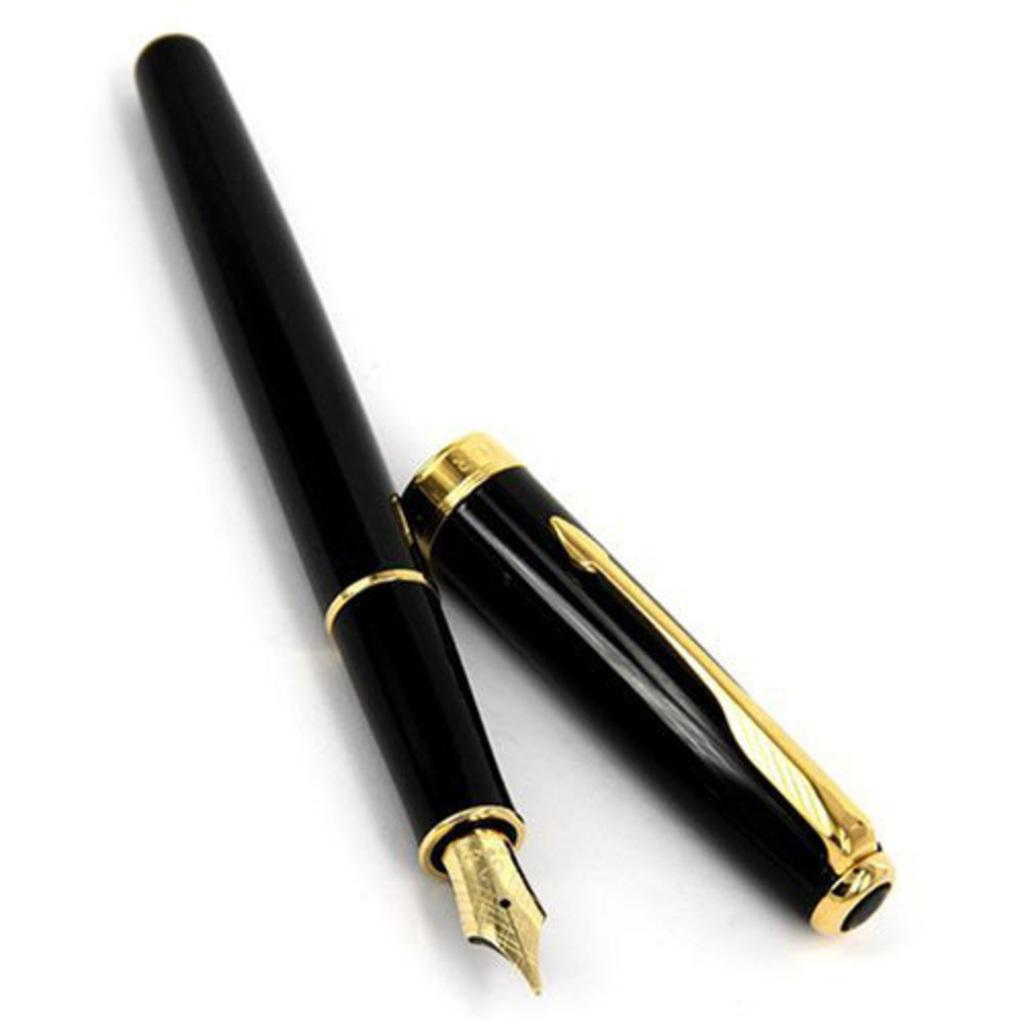What object can be seen in the image? There is a pen in the image. Can you describe the pen's appearance? The pen is black and gold in color. How many apples are hanging from the pen in the image? There are no apples present in the image, as it features a pen with a black and gold color scheme. What type of learning material is associated with the pen in the image? There is no learning material explicitly associated with the pen in the image. 